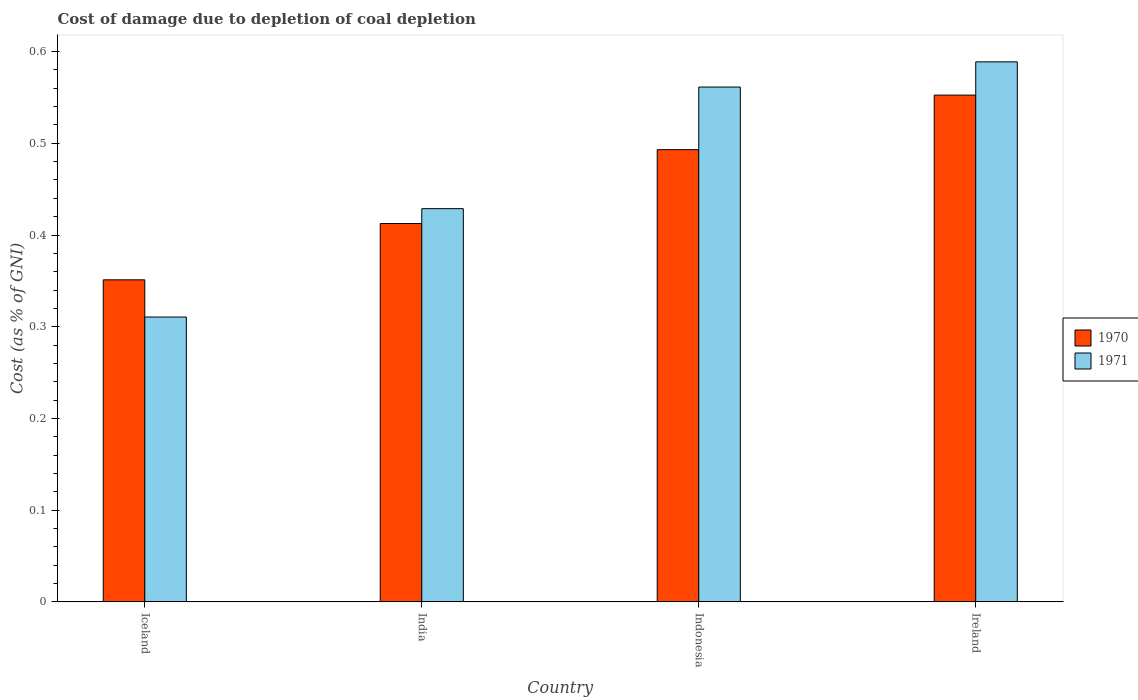How many different coloured bars are there?
Offer a terse response. 2. How many groups of bars are there?
Offer a terse response. 4. Are the number of bars on each tick of the X-axis equal?
Provide a short and direct response. Yes. What is the label of the 2nd group of bars from the left?
Give a very brief answer. India. What is the cost of damage caused due to coal depletion in 1971 in India?
Your response must be concise. 0.43. Across all countries, what is the maximum cost of damage caused due to coal depletion in 1970?
Make the answer very short. 0.55. Across all countries, what is the minimum cost of damage caused due to coal depletion in 1971?
Make the answer very short. 0.31. In which country was the cost of damage caused due to coal depletion in 1970 maximum?
Your answer should be very brief. Ireland. What is the total cost of damage caused due to coal depletion in 1971 in the graph?
Ensure brevity in your answer.  1.89. What is the difference between the cost of damage caused due to coal depletion in 1971 in India and that in Ireland?
Offer a terse response. -0.16. What is the difference between the cost of damage caused due to coal depletion in 1971 in Indonesia and the cost of damage caused due to coal depletion in 1970 in India?
Offer a terse response. 0.15. What is the average cost of damage caused due to coal depletion in 1971 per country?
Your answer should be very brief. 0.47. What is the difference between the cost of damage caused due to coal depletion of/in 1971 and cost of damage caused due to coal depletion of/in 1970 in India?
Ensure brevity in your answer.  0.02. What is the ratio of the cost of damage caused due to coal depletion in 1970 in India to that in Indonesia?
Give a very brief answer. 0.84. What is the difference between the highest and the second highest cost of damage caused due to coal depletion in 1971?
Ensure brevity in your answer.  0.03. What is the difference between the highest and the lowest cost of damage caused due to coal depletion in 1971?
Give a very brief answer. 0.28. What does the 2nd bar from the left in India represents?
Make the answer very short. 1971. What does the 1st bar from the right in Iceland represents?
Your answer should be compact. 1971. Are all the bars in the graph horizontal?
Your response must be concise. No. How many countries are there in the graph?
Ensure brevity in your answer.  4. What is the difference between two consecutive major ticks on the Y-axis?
Give a very brief answer. 0.1. Are the values on the major ticks of Y-axis written in scientific E-notation?
Offer a terse response. No. How are the legend labels stacked?
Make the answer very short. Vertical. What is the title of the graph?
Your answer should be compact. Cost of damage due to depletion of coal depletion. What is the label or title of the X-axis?
Your answer should be very brief. Country. What is the label or title of the Y-axis?
Provide a succinct answer. Cost (as % of GNI). What is the Cost (as % of GNI) in 1970 in Iceland?
Offer a very short reply. 0.35. What is the Cost (as % of GNI) in 1971 in Iceland?
Make the answer very short. 0.31. What is the Cost (as % of GNI) in 1970 in India?
Your response must be concise. 0.41. What is the Cost (as % of GNI) in 1971 in India?
Your answer should be compact. 0.43. What is the Cost (as % of GNI) of 1970 in Indonesia?
Provide a short and direct response. 0.49. What is the Cost (as % of GNI) of 1971 in Indonesia?
Make the answer very short. 0.56. What is the Cost (as % of GNI) in 1970 in Ireland?
Ensure brevity in your answer.  0.55. What is the Cost (as % of GNI) in 1971 in Ireland?
Your answer should be very brief. 0.59. Across all countries, what is the maximum Cost (as % of GNI) of 1970?
Offer a very short reply. 0.55. Across all countries, what is the maximum Cost (as % of GNI) in 1971?
Offer a very short reply. 0.59. Across all countries, what is the minimum Cost (as % of GNI) in 1970?
Your answer should be compact. 0.35. Across all countries, what is the minimum Cost (as % of GNI) of 1971?
Offer a terse response. 0.31. What is the total Cost (as % of GNI) of 1970 in the graph?
Keep it short and to the point. 1.81. What is the total Cost (as % of GNI) in 1971 in the graph?
Your answer should be very brief. 1.89. What is the difference between the Cost (as % of GNI) of 1970 in Iceland and that in India?
Keep it short and to the point. -0.06. What is the difference between the Cost (as % of GNI) in 1971 in Iceland and that in India?
Your response must be concise. -0.12. What is the difference between the Cost (as % of GNI) of 1970 in Iceland and that in Indonesia?
Keep it short and to the point. -0.14. What is the difference between the Cost (as % of GNI) in 1971 in Iceland and that in Indonesia?
Your answer should be very brief. -0.25. What is the difference between the Cost (as % of GNI) in 1970 in Iceland and that in Ireland?
Your answer should be very brief. -0.2. What is the difference between the Cost (as % of GNI) of 1971 in Iceland and that in Ireland?
Your response must be concise. -0.28. What is the difference between the Cost (as % of GNI) in 1970 in India and that in Indonesia?
Make the answer very short. -0.08. What is the difference between the Cost (as % of GNI) in 1971 in India and that in Indonesia?
Your response must be concise. -0.13. What is the difference between the Cost (as % of GNI) in 1970 in India and that in Ireland?
Your answer should be very brief. -0.14. What is the difference between the Cost (as % of GNI) of 1971 in India and that in Ireland?
Ensure brevity in your answer.  -0.16. What is the difference between the Cost (as % of GNI) of 1970 in Indonesia and that in Ireland?
Make the answer very short. -0.06. What is the difference between the Cost (as % of GNI) in 1971 in Indonesia and that in Ireland?
Offer a very short reply. -0.03. What is the difference between the Cost (as % of GNI) in 1970 in Iceland and the Cost (as % of GNI) in 1971 in India?
Give a very brief answer. -0.08. What is the difference between the Cost (as % of GNI) in 1970 in Iceland and the Cost (as % of GNI) in 1971 in Indonesia?
Your response must be concise. -0.21. What is the difference between the Cost (as % of GNI) in 1970 in Iceland and the Cost (as % of GNI) in 1971 in Ireland?
Your answer should be very brief. -0.24. What is the difference between the Cost (as % of GNI) of 1970 in India and the Cost (as % of GNI) of 1971 in Indonesia?
Give a very brief answer. -0.15. What is the difference between the Cost (as % of GNI) in 1970 in India and the Cost (as % of GNI) in 1971 in Ireland?
Your answer should be compact. -0.18. What is the difference between the Cost (as % of GNI) of 1970 in Indonesia and the Cost (as % of GNI) of 1971 in Ireland?
Your response must be concise. -0.1. What is the average Cost (as % of GNI) of 1970 per country?
Ensure brevity in your answer.  0.45. What is the average Cost (as % of GNI) in 1971 per country?
Offer a terse response. 0.47. What is the difference between the Cost (as % of GNI) of 1970 and Cost (as % of GNI) of 1971 in Iceland?
Provide a short and direct response. 0.04. What is the difference between the Cost (as % of GNI) of 1970 and Cost (as % of GNI) of 1971 in India?
Keep it short and to the point. -0.02. What is the difference between the Cost (as % of GNI) of 1970 and Cost (as % of GNI) of 1971 in Indonesia?
Keep it short and to the point. -0.07. What is the difference between the Cost (as % of GNI) in 1970 and Cost (as % of GNI) in 1971 in Ireland?
Offer a very short reply. -0.04. What is the ratio of the Cost (as % of GNI) in 1970 in Iceland to that in India?
Provide a succinct answer. 0.85. What is the ratio of the Cost (as % of GNI) of 1971 in Iceland to that in India?
Your response must be concise. 0.72. What is the ratio of the Cost (as % of GNI) of 1970 in Iceland to that in Indonesia?
Make the answer very short. 0.71. What is the ratio of the Cost (as % of GNI) of 1971 in Iceland to that in Indonesia?
Keep it short and to the point. 0.55. What is the ratio of the Cost (as % of GNI) in 1970 in Iceland to that in Ireland?
Keep it short and to the point. 0.64. What is the ratio of the Cost (as % of GNI) of 1971 in Iceland to that in Ireland?
Your answer should be very brief. 0.53. What is the ratio of the Cost (as % of GNI) in 1970 in India to that in Indonesia?
Provide a short and direct response. 0.84. What is the ratio of the Cost (as % of GNI) in 1971 in India to that in Indonesia?
Your answer should be very brief. 0.76. What is the ratio of the Cost (as % of GNI) of 1970 in India to that in Ireland?
Make the answer very short. 0.75. What is the ratio of the Cost (as % of GNI) of 1971 in India to that in Ireland?
Give a very brief answer. 0.73. What is the ratio of the Cost (as % of GNI) in 1970 in Indonesia to that in Ireland?
Offer a terse response. 0.89. What is the ratio of the Cost (as % of GNI) of 1971 in Indonesia to that in Ireland?
Keep it short and to the point. 0.95. What is the difference between the highest and the second highest Cost (as % of GNI) in 1970?
Your answer should be very brief. 0.06. What is the difference between the highest and the second highest Cost (as % of GNI) in 1971?
Offer a very short reply. 0.03. What is the difference between the highest and the lowest Cost (as % of GNI) of 1970?
Provide a succinct answer. 0.2. What is the difference between the highest and the lowest Cost (as % of GNI) of 1971?
Provide a short and direct response. 0.28. 